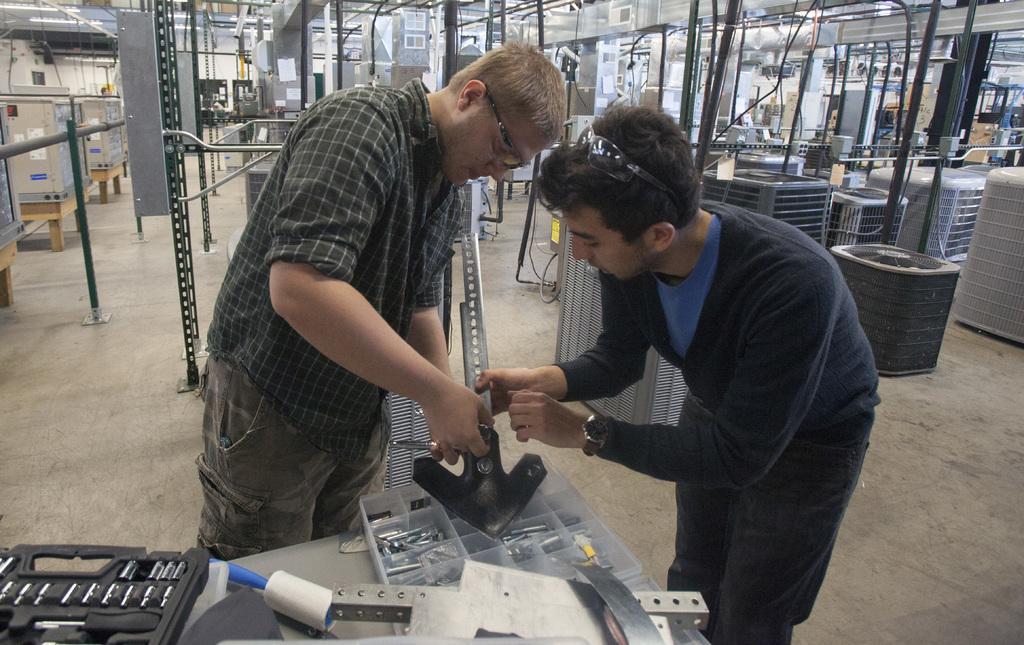Describe this image in one or two sentences. In this picture we can see two men are standing and holding something, in the background there are some metal rods and equipment, at the bottom there is a table, we can see a plastic box and some metallic things present on the table, a man on the left side wore spectacles, a man on the right wore a watch. 